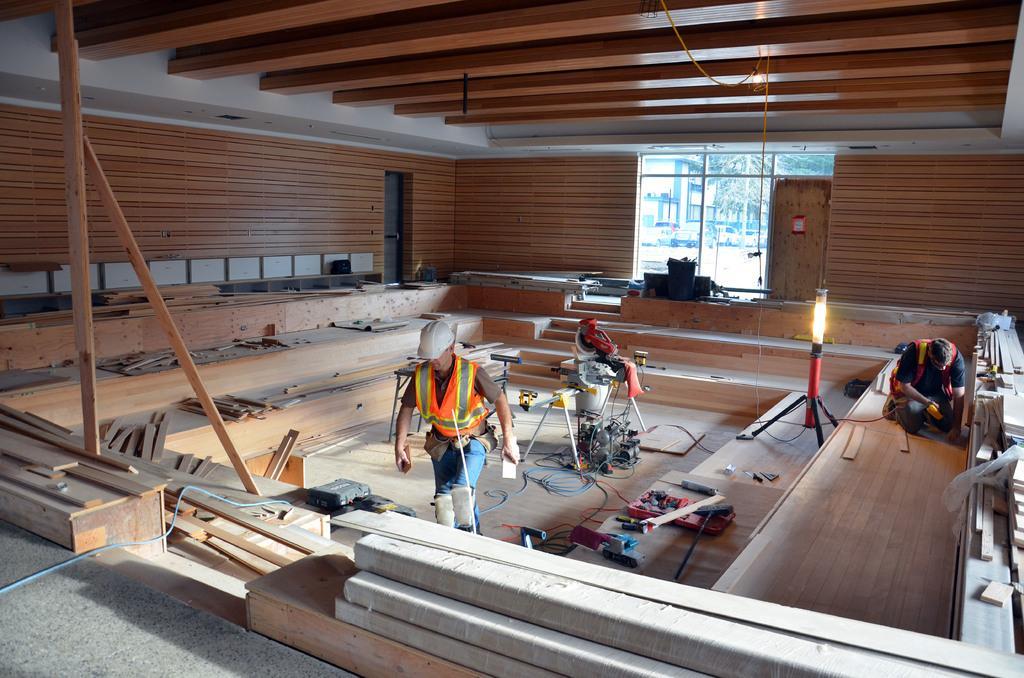Please provide a concise description of this image. In this image I can see two persons on the floor, machines, lamp stand and tools. In the background I can see a wall, window, door and a rooftop. This image is taken in a hall. 